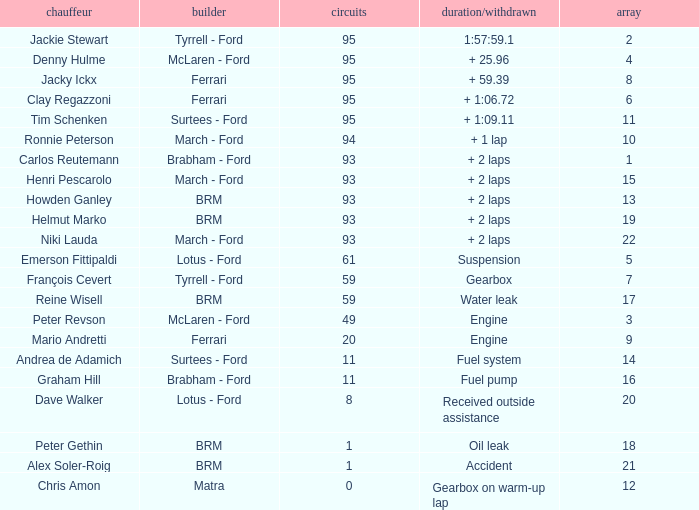What is the largest number of laps with a Grid larger than 14, a Time/Retired of + 2 laps, and a Driver of helmut marko? 93.0. 